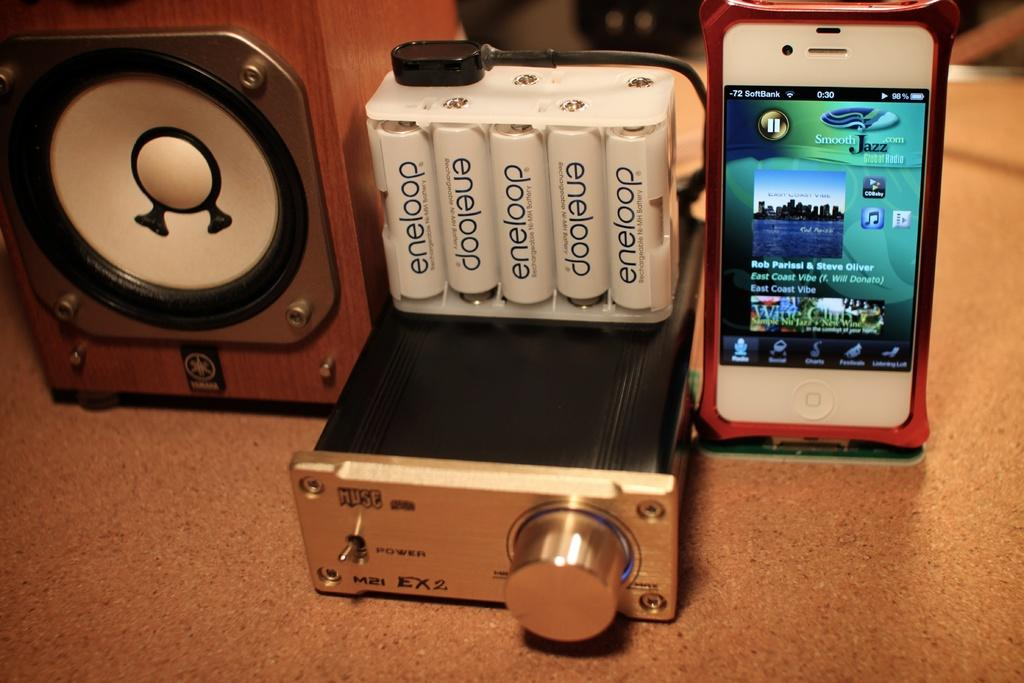Provide a one-sentence caption for the provided image. A  white iphone hooked up to a device and a case of Eneloop brand batteries in a clear case beside. 